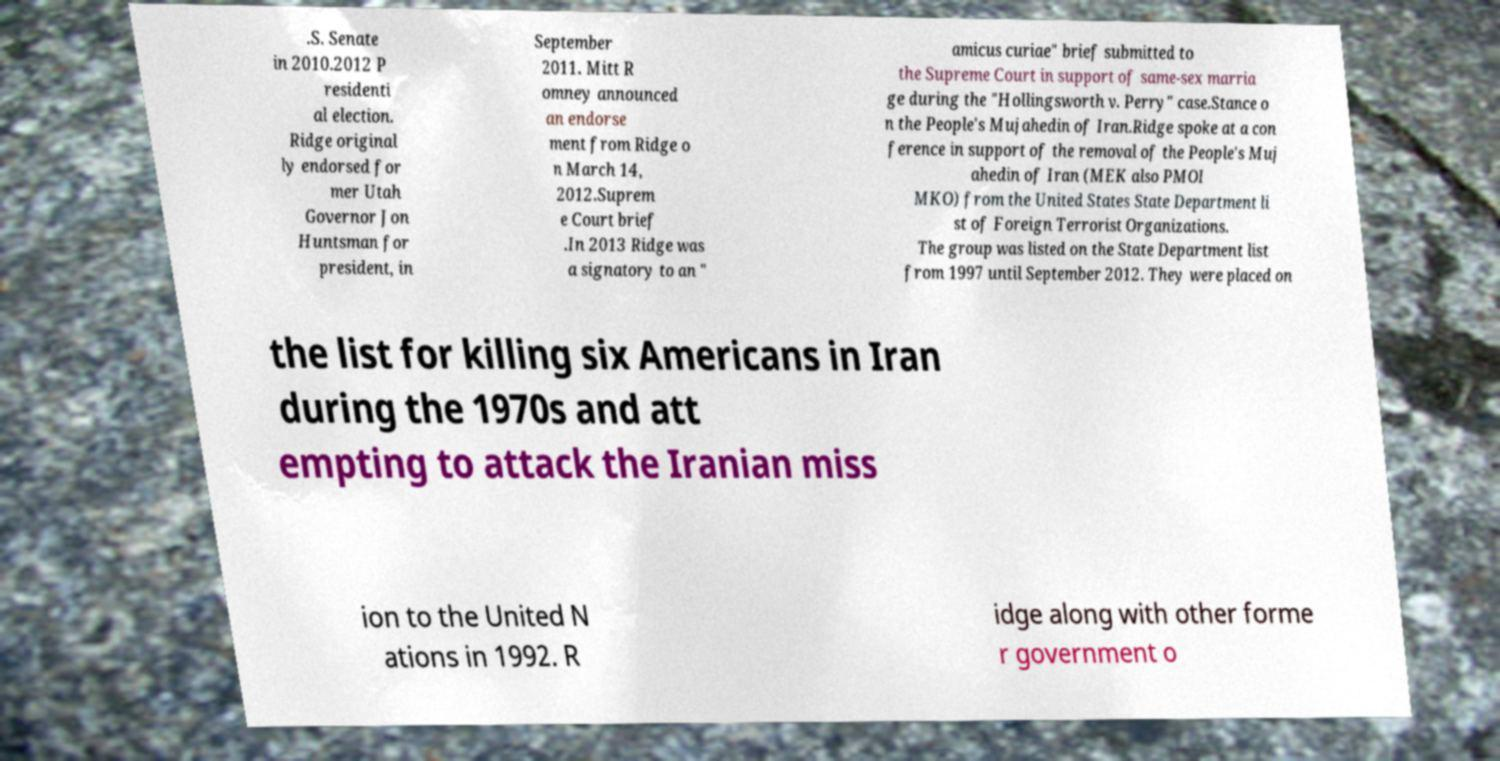What messages or text are displayed in this image? I need them in a readable, typed format. .S. Senate in 2010.2012 P residenti al election. Ridge original ly endorsed for mer Utah Governor Jon Huntsman for president, in September 2011. Mitt R omney announced an endorse ment from Ridge o n March 14, 2012.Suprem e Court brief .In 2013 Ridge was a signatory to an " amicus curiae" brief submitted to the Supreme Court in support of same-sex marria ge during the "Hollingsworth v. Perry" case.Stance o n the People's Mujahedin of Iran.Ridge spoke at a con ference in support of the removal of the People's Muj ahedin of Iran (MEK also PMOI MKO) from the United States State Department li st of Foreign Terrorist Organizations. The group was listed on the State Department list from 1997 until September 2012. They were placed on the list for killing six Americans in Iran during the 1970s and att empting to attack the Iranian miss ion to the United N ations in 1992. R idge along with other forme r government o 